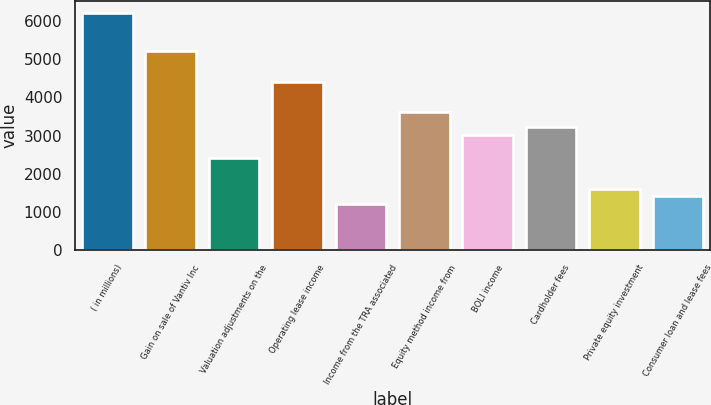Convert chart to OTSL. <chart><loc_0><loc_0><loc_500><loc_500><bar_chart><fcel>( in millions)<fcel>Gain on sale of Vantiv Inc<fcel>Valuation adjustments on the<fcel>Operating lease income<fcel>Income from the TRA associated<fcel>Equity method income from<fcel>BOLI income<fcel>Cardholder fees<fcel>Private equity investment<fcel>Consumer loan and lease fees<nl><fcel>6218.2<fcel>5217.2<fcel>2414.4<fcel>4416.4<fcel>1213.2<fcel>3615.6<fcel>3015<fcel>3215.2<fcel>1613.6<fcel>1413.4<nl></chart> 